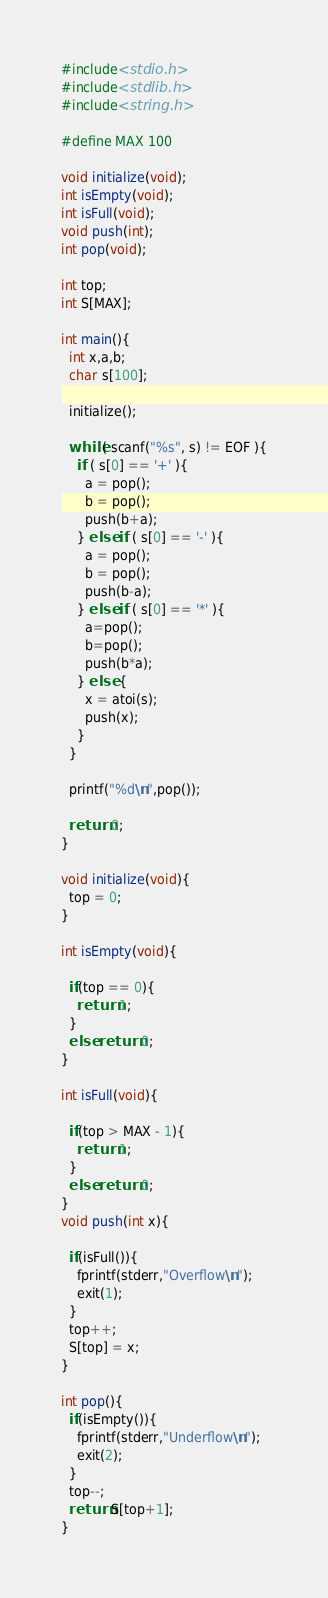Convert code to text. <code><loc_0><loc_0><loc_500><loc_500><_C_>#include<stdio.h>
#include<stdlib.h>
#include<string.h>

#define MAX 100

void initialize(void);
int isEmpty(void);
int isFull(void);
void push(int);
int pop(void);

int top;
int S[MAX];

int main(){
  int x,a,b;
  char s[100];

  initialize();

  while( scanf("%s", s) != EOF ){
    if ( s[0] == '+' ){
      a = pop();
      b = pop();
      push(b+a);
    } else if ( s[0] == '-' ){
      a = pop();
      b = pop();
      push(b-a);
    } else if ( s[0] == '*' ){
      a=pop();
      b=pop();
      push(b*a);
    } else {
      x = atoi(s);
      push(x);
    }
  }

  printf("%d\n",pop());

  return 0;
}

void initialize(void){
  top = 0;
}

int isEmpty(void){

  if(top == 0){
    return 1;
  }
  else return 0;
}

int isFull(void){

  if(top > MAX - 1){
    return 1;
  }
  else return 0;
}
void push(int x){

  if(isFull()){
    fprintf(stderr,"Overflow\n");
    exit(1);  
  }
  top++;
  S[top] = x;
}

int pop(){
  if(isEmpty()){
    fprintf(stderr,"Underflow\n");
    exit(2);
  }
  top--;
  return S[top+1];
}</code> 